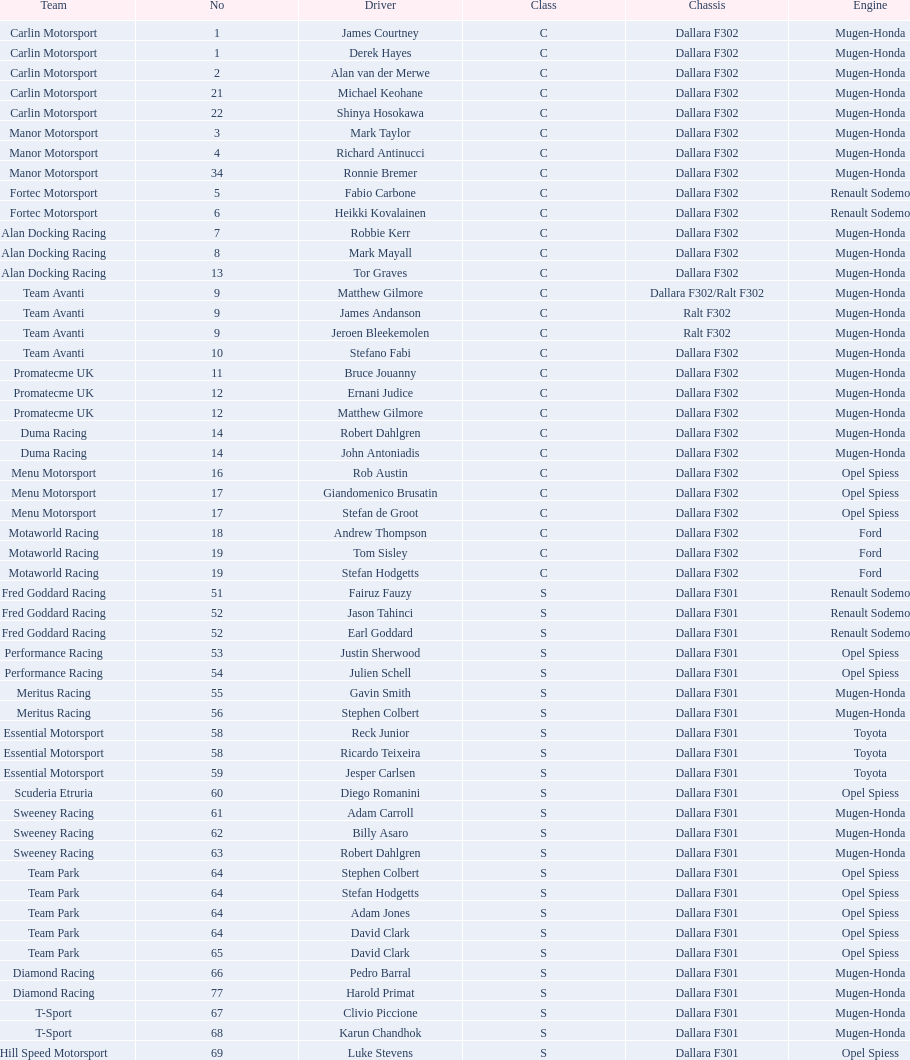Along with clivio piccione, who is the second driver for t-sport? Karun Chandhok. 